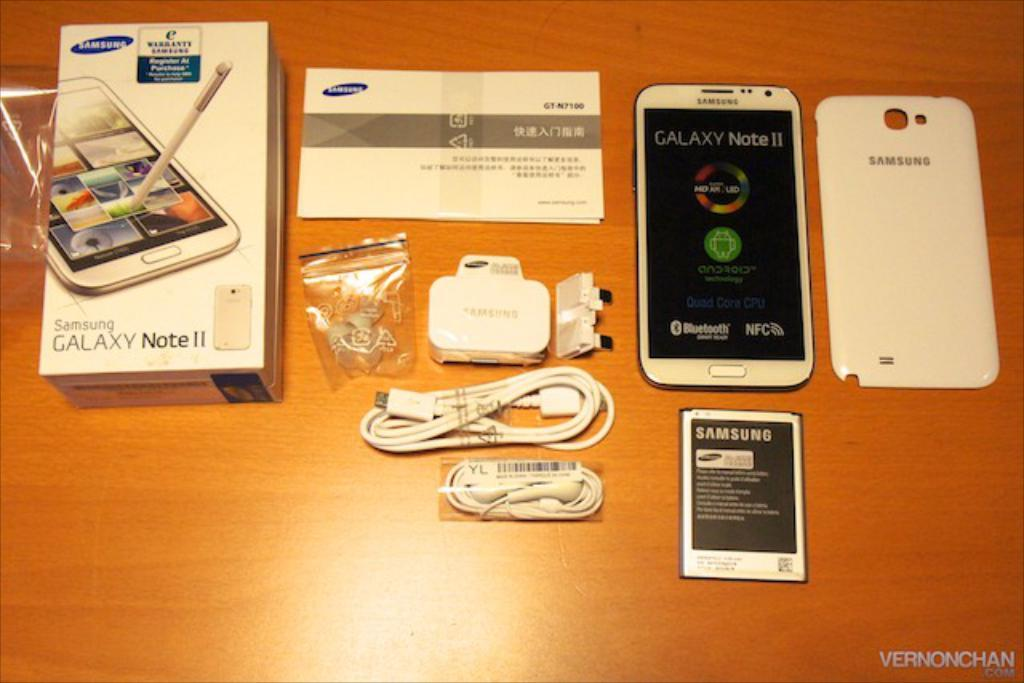<image>
Offer a succinct explanation of the picture presented. All of the contents for a Galaxy Note II is on a table. 